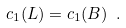Convert formula to latex. <formula><loc_0><loc_0><loc_500><loc_500>c _ { 1 } ( L ) = c _ { 1 } ( B ) \ .</formula> 